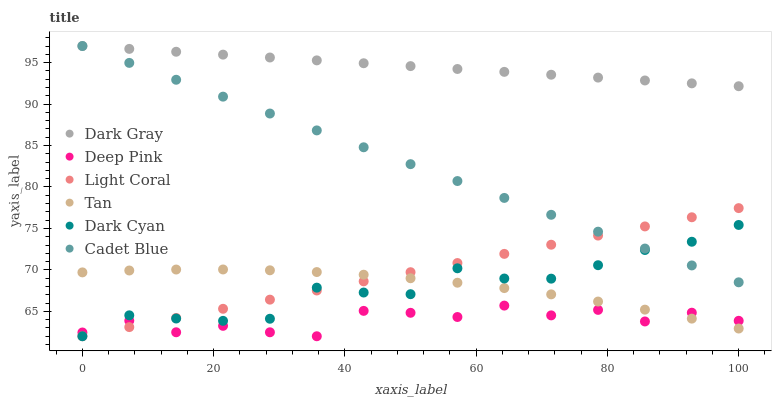Does Deep Pink have the minimum area under the curve?
Answer yes or no. Yes. Does Dark Gray have the maximum area under the curve?
Answer yes or no. Yes. Does Dark Gray have the minimum area under the curve?
Answer yes or no. No. Does Deep Pink have the maximum area under the curve?
Answer yes or no. No. Is Cadet Blue the smoothest?
Answer yes or no. Yes. Is Deep Pink the roughest?
Answer yes or no. Yes. Is Dark Gray the smoothest?
Answer yes or no. No. Is Dark Gray the roughest?
Answer yes or no. No. Does Light Coral have the lowest value?
Answer yes or no. Yes. Does Dark Gray have the lowest value?
Answer yes or no. No. Does Cadet Blue have the highest value?
Answer yes or no. Yes. Does Deep Pink have the highest value?
Answer yes or no. No. Is Deep Pink less than Dark Gray?
Answer yes or no. Yes. Is Dark Gray greater than Light Coral?
Answer yes or no. Yes. Does Cadet Blue intersect Dark Gray?
Answer yes or no. Yes. Is Cadet Blue less than Dark Gray?
Answer yes or no. No. Is Cadet Blue greater than Dark Gray?
Answer yes or no. No. Does Deep Pink intersect Dark Gray?
Answer yes or no. No. 